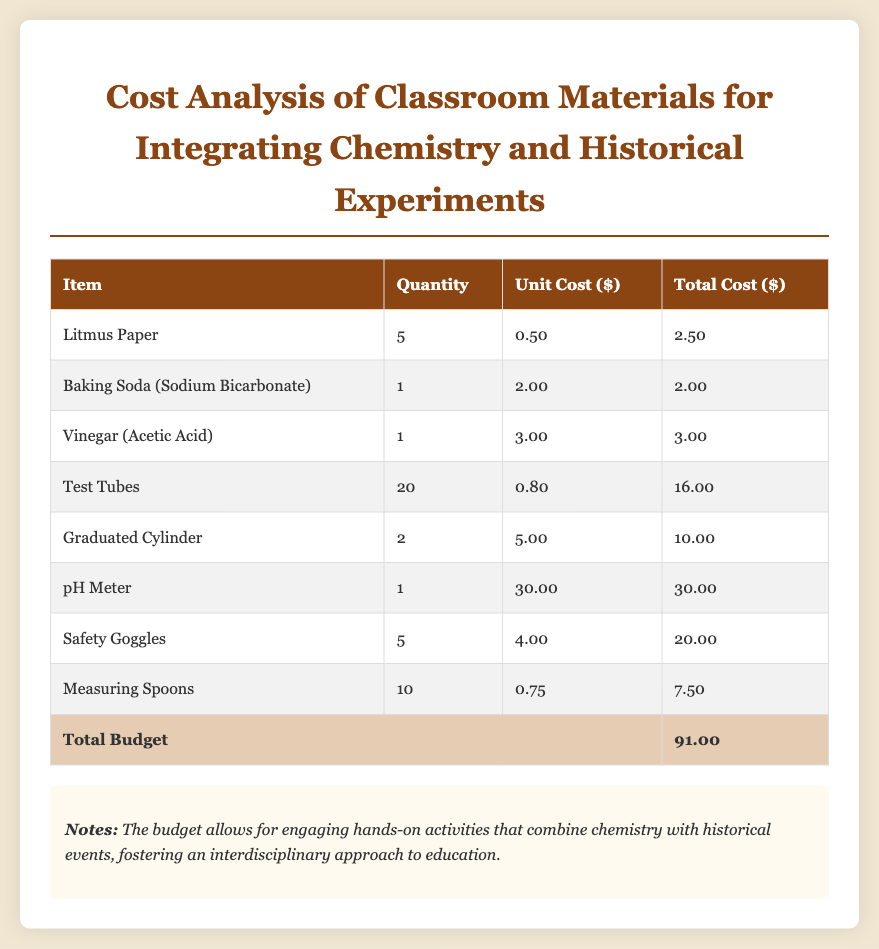What is the total budget? The total budget is stated in the last row of the table, which sums up the costs of all items.
Answer: 91.00 How many test tubes are included in the budget? The number of test tubes can be found in the table under Quantity for the Test Tubes item.
Answer: 20 What is the unit cost of the pH meter? The unit cost of the pH meter is listed in the table next to the pH Meter item.
Answer: 30.00 What item has the highest total cost? The highest total cost can be determined by looking at the Total Cost column in the table.
Answer: pH Meter How many safety goggles are included in the budget? The budget specifies the quantity of safety goggles in the table under Quantity for the Safety Goggles item.
Answer: 5 What is the total cost of baking soda? The total cost for baking soda can be found next to the Baking Soda (Sodium Bicarbonate) item in the table.
Answer: 2.00 Which item has a unit cost of 0.50? The item with a unit cost of 0.50 is listed in the table.
Answer: Litmus Paper What is the total cost for safety goggles? The total cost for safety goggles is mentioned in the total cost column of the safety goggles item.
Answer: 20.00 How many measuring spoons are being purchased? The number of measuring spoons is indicated in the Quantity column of the table.
Answer: 10 